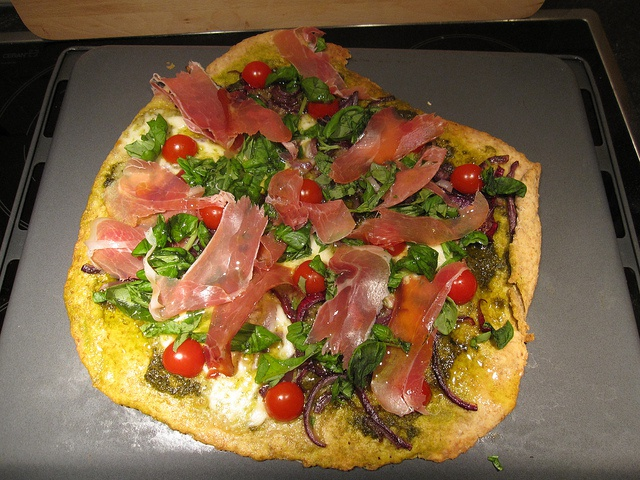Describe the objects in this image and their specific colors. I can see oven in black, gray, brown, olive, and maroon tones and pizza in black, brown, olive, tan, and maroon tones in this image. 